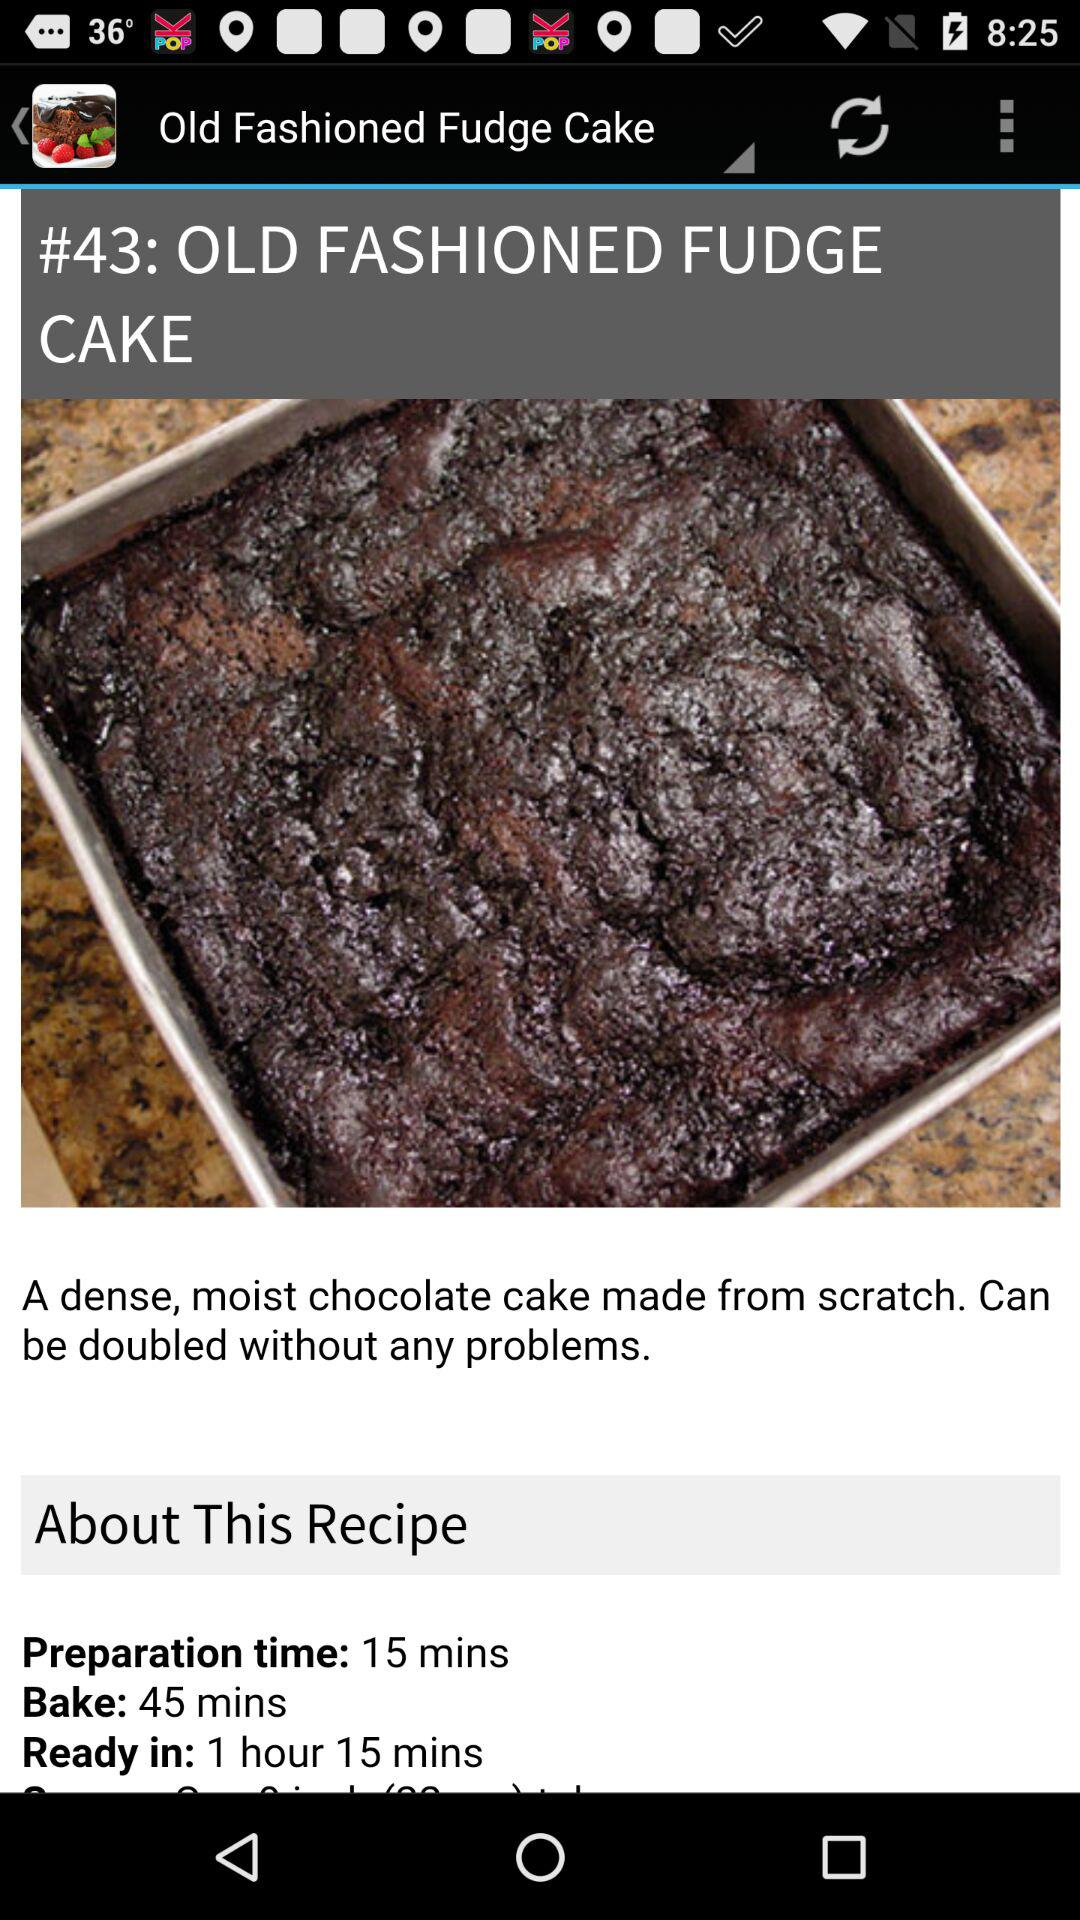How many more minutes is the bake time than the preparation time?
Answer the question using a single word or phrase. 30 